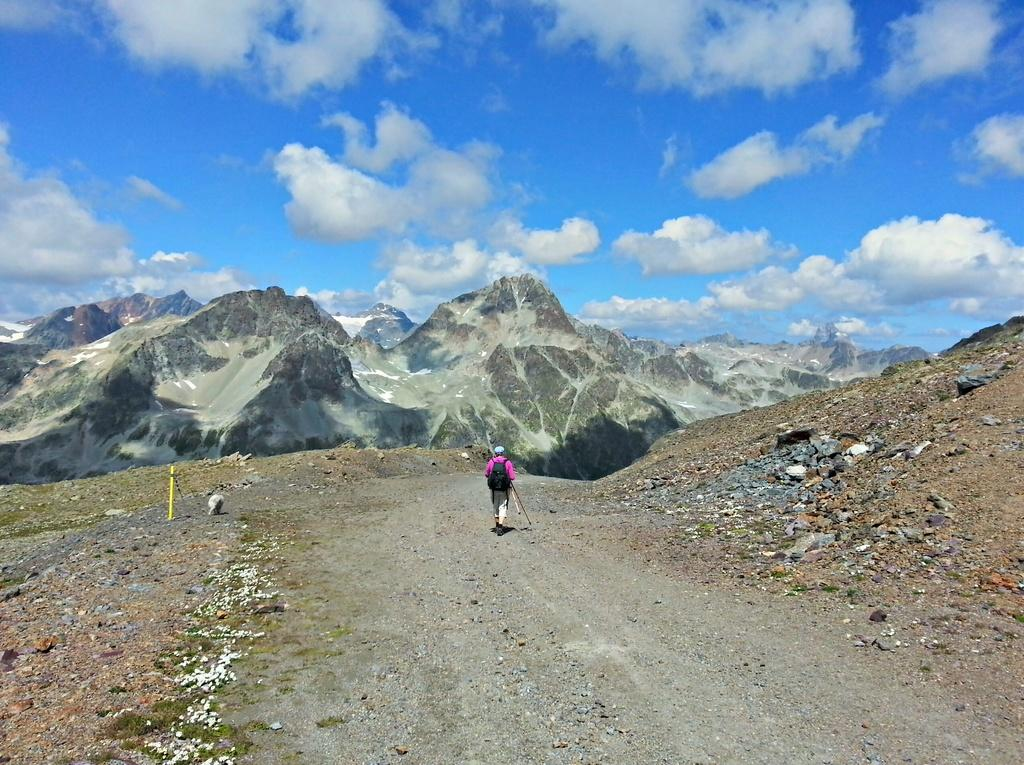What is the person in the image carrying on their back? There is a person with a backpack in the image. What type of terrain is visible in the image? There are rocks and mountains in the image. What can be seen in the background of the image? The sky is visible in the background of the image. What type of veil is the person wearing in the image? There is no veil present in the image; the person is wearing a backpack. What type of shoes can be seen on the person's feet in the image? The image does not show the person's feet, so it is not possible to determine the type of shoes they might be wearing. 